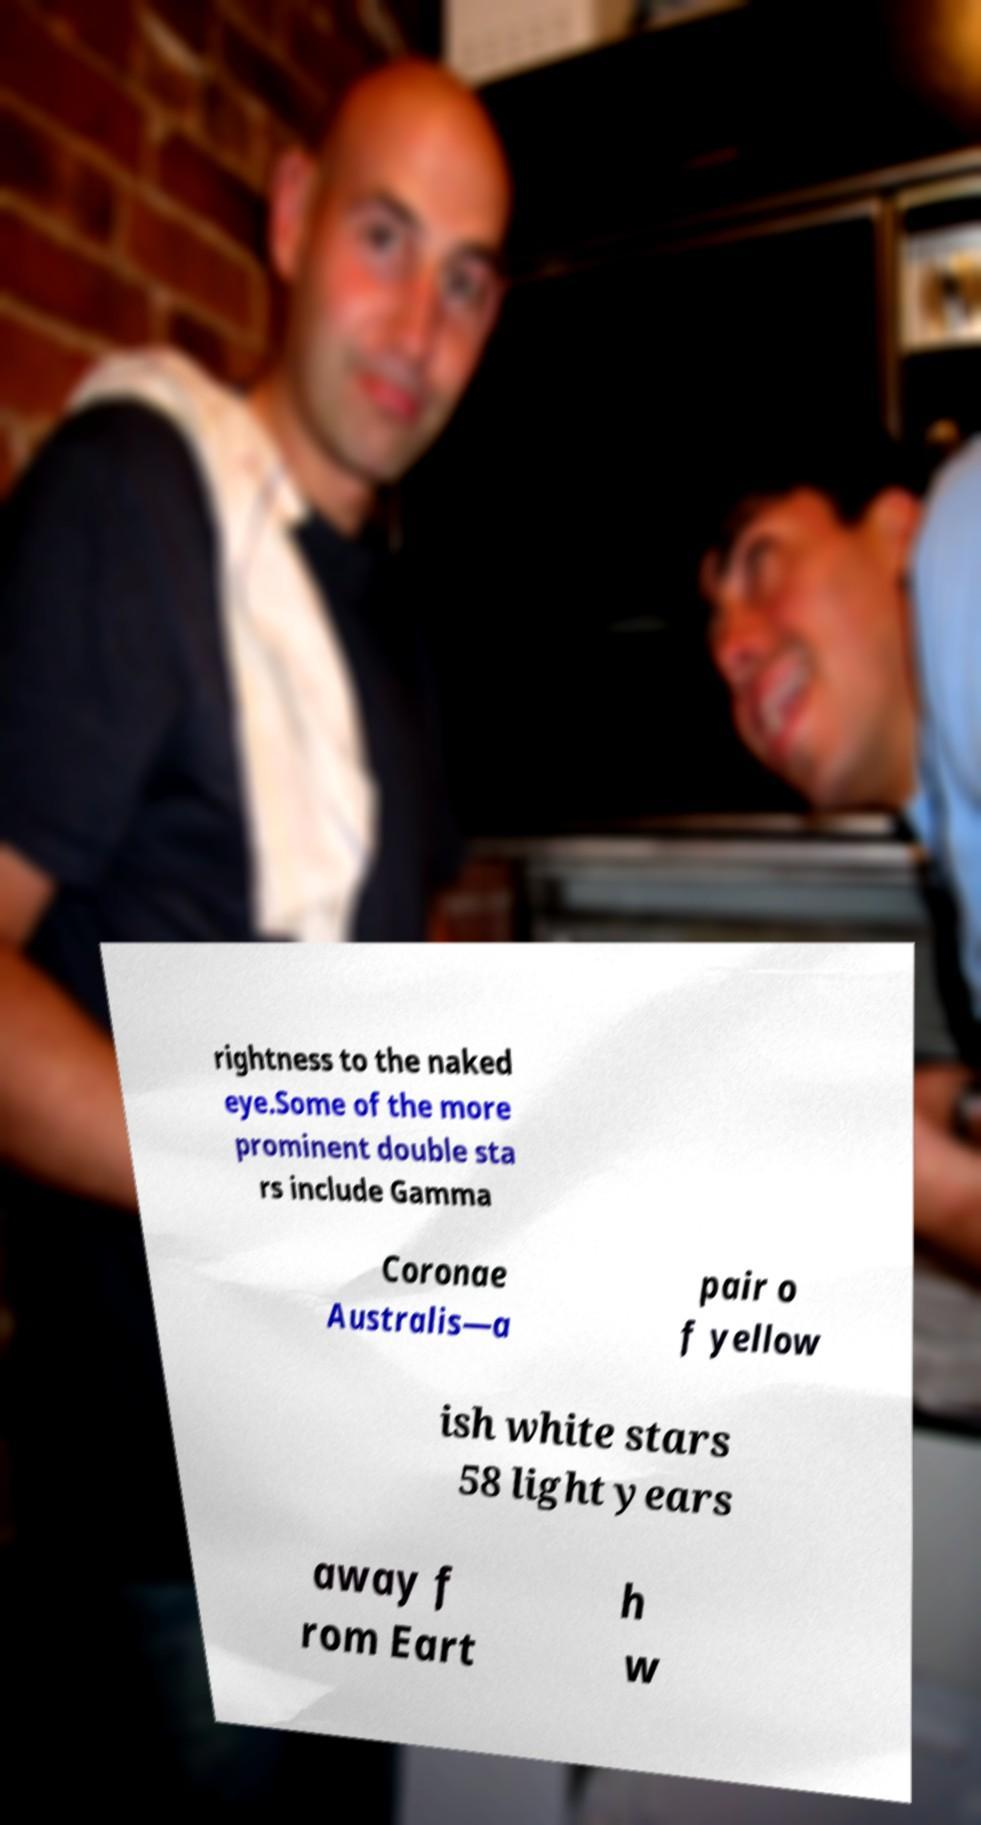What messages or text are displayed in this image? I need them in a readable, typed format. rightness to the naked eye.Some of the more prominent double sta rs include Gamma Coronae Australis—a pair o f yellow ish white stars 58 light years away f rom Eart h w 